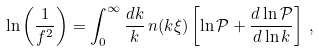<formula> <loc_0><loc_0><loc_500><loc_500>\ln \left ( \frac { 1 } { f ^ { 2 } } \right ) = \int _ { 0 } ^ { \infty } \frac { d k } { k } \, n ( k \xi ) \left [ \ln \mathcal { P } + \frac { d \ln \mathcal { P } } { d \ln k } \right ] \, ,</formula> 